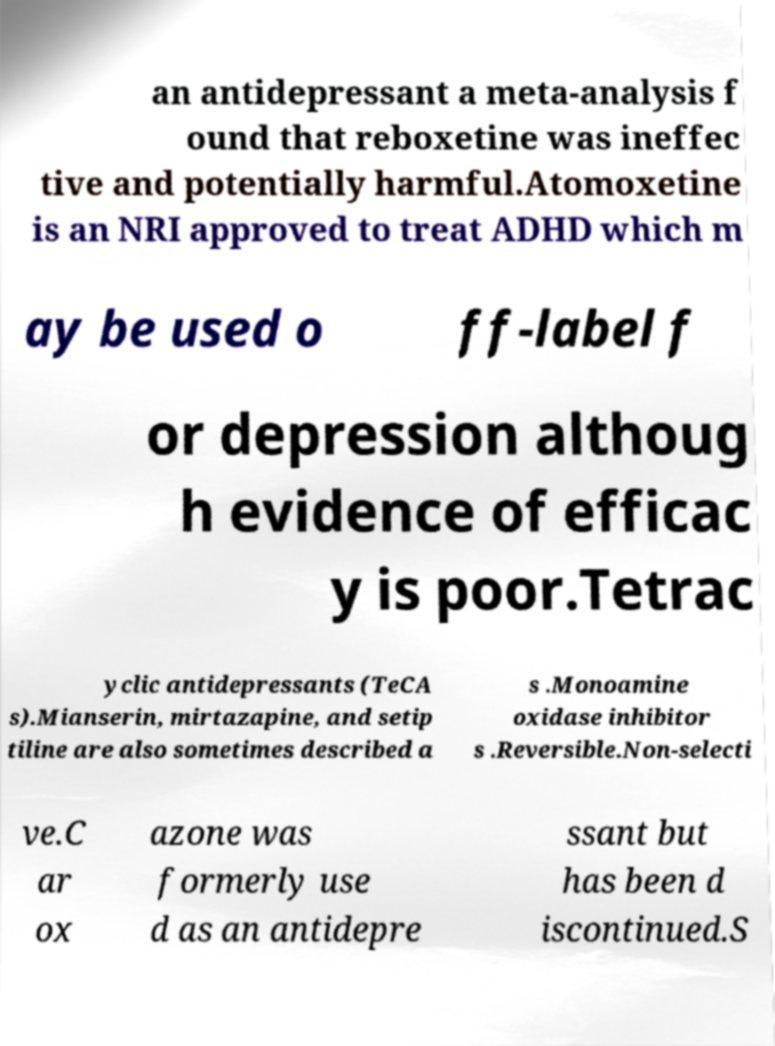There's text embedded in this image that I need extracted. Can you transcribe it verbatim? an antidepressant a meta-analysis f ound that reboxetine was ineffec tive and potentially harmful.Atomoxetine is an NRI approved to treat ADHD which m ay be used o ff-label f or depression althoug h evidence of efficac y is poor.Tetrac yclic antidepressants (TeCA s).Mianserin, mirtazapine, and setip tiline are also sometimes described a s .Monoamine oxidase inhibitor s .Reversible.Non-selecti ve.C ar ox azone was formerly use d as an antidepre ssant but has been d iscontinued.S 